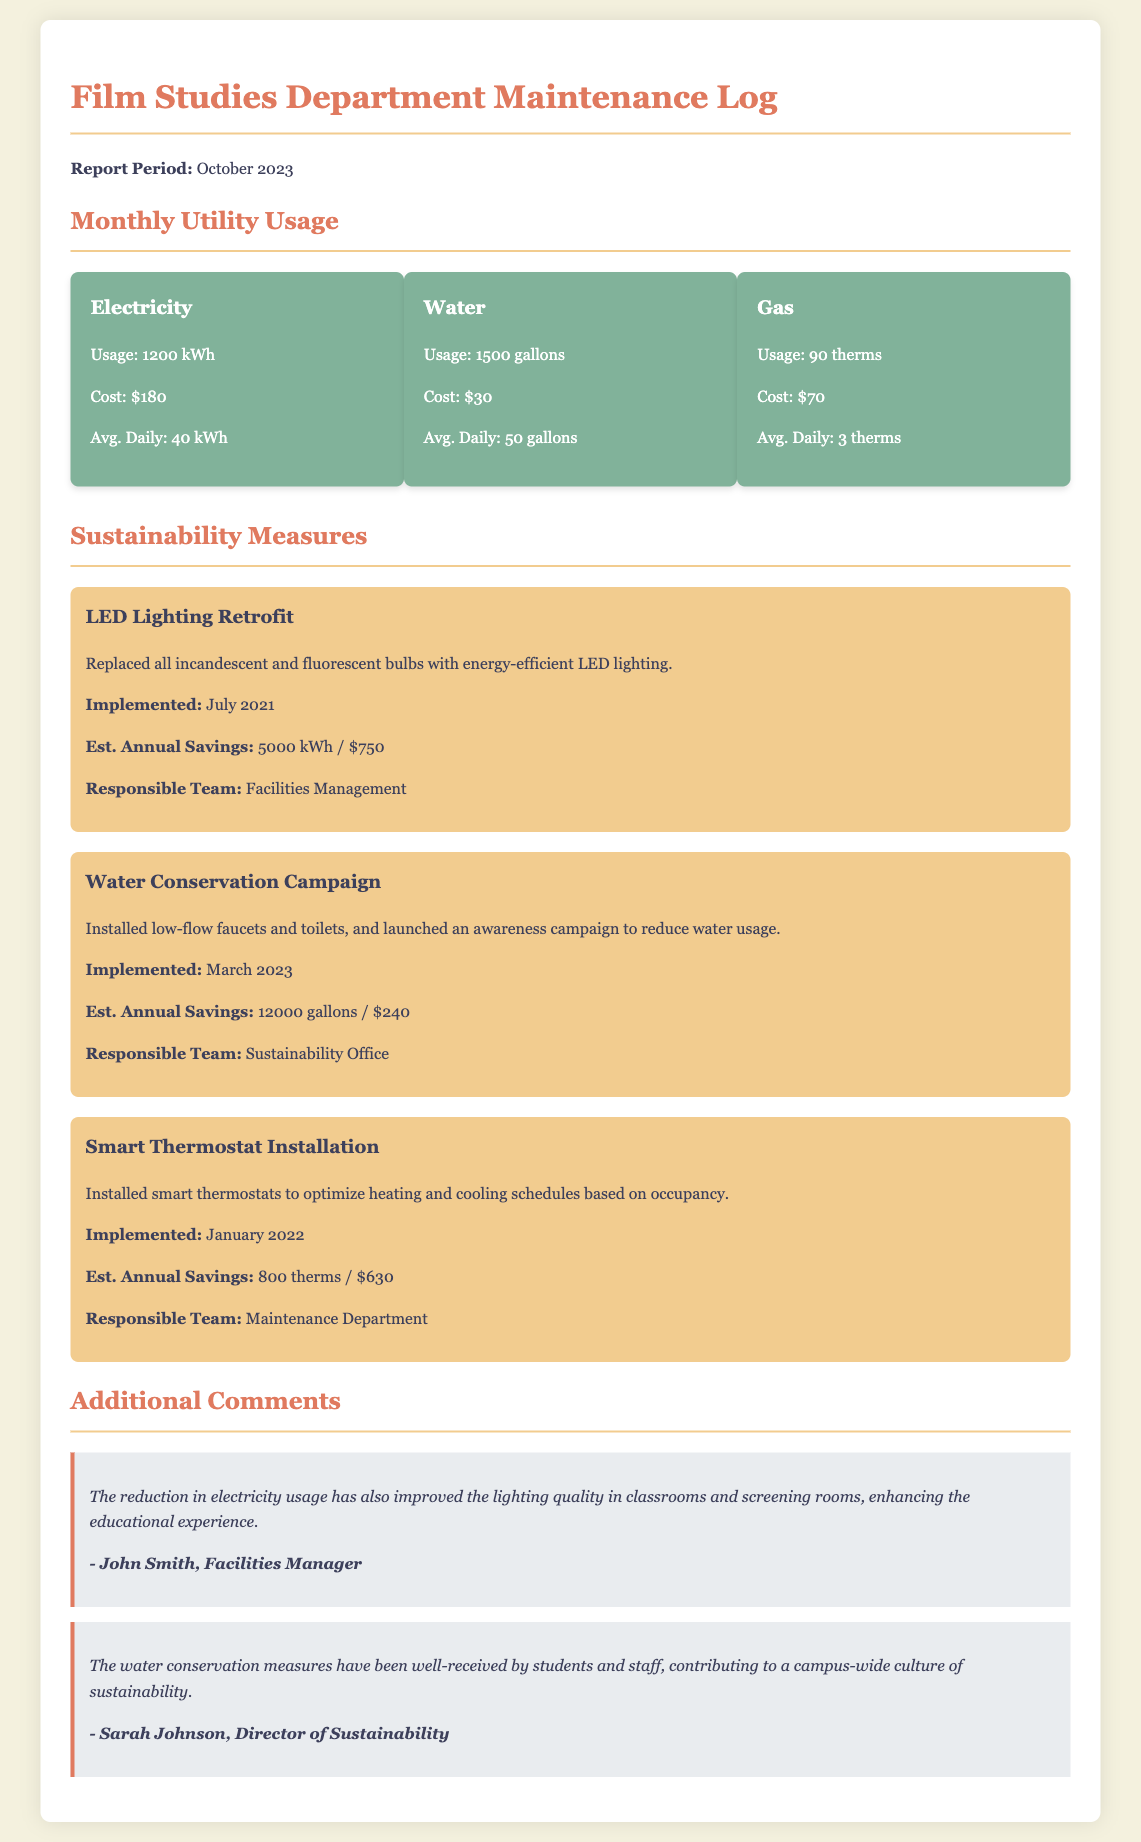What is the electricity usage for October 2023? The document states that the electricity usage for October 2023 is 1200 kWh.
Answer: 1200 kWh What was the total cost of water usage? The document indicates that the cost of water usage for October 2023 is $30.
Answer: $30 When was the LED Lighting Retrofit implemented? According to the document, the LED Lighting Retrofit was implemented in July 2021.
Answer: July 2021 What is the estimated annual savings from the Water Conservation Campaign? The document lists the estimated annual savings from the Water Conservation Campaign as 12000 gallons / $240.
Answer: 12000 gallons / $240 How much is the average daily gas usage? The average daily gas usage according to the document is 3 therms.
Answer: 3 therms What sustainability measure was implemented in March 2023? The document details that the Water Conservation Campaign was implemented in March 2023.
Answer: Water Conservation Campaign Who is responsible for the smart thermostat installation? The document states that the Maintenance Department is responsible for the smart thermostat installation.
Answer: Maintenance Department What impact has the reduction in electricity usage had on classrooms? The document mentions that the reduction in electricity usage has improved lighting quality in classrooms.
Answer: Improved lighting quality How many gallons of water did the department use in October 2023? The document states that the water usage in October 2023 was 1500 gallons.
Answer: 1500 gallons 